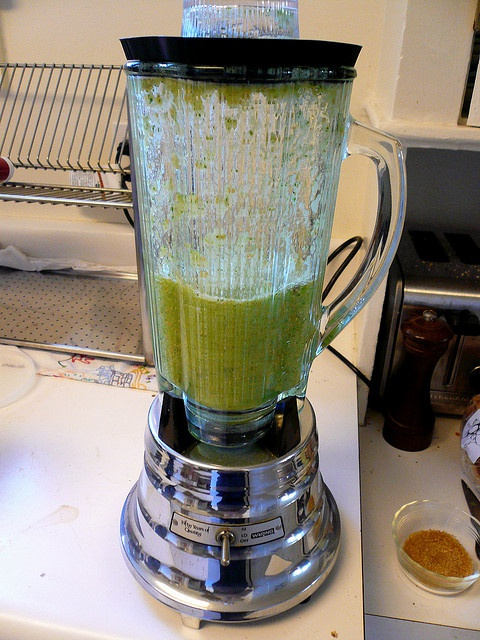Describe the objects in this image and their specific colors. I can see a bowl in gray, olive, tan, and darkgray tones in this image. 